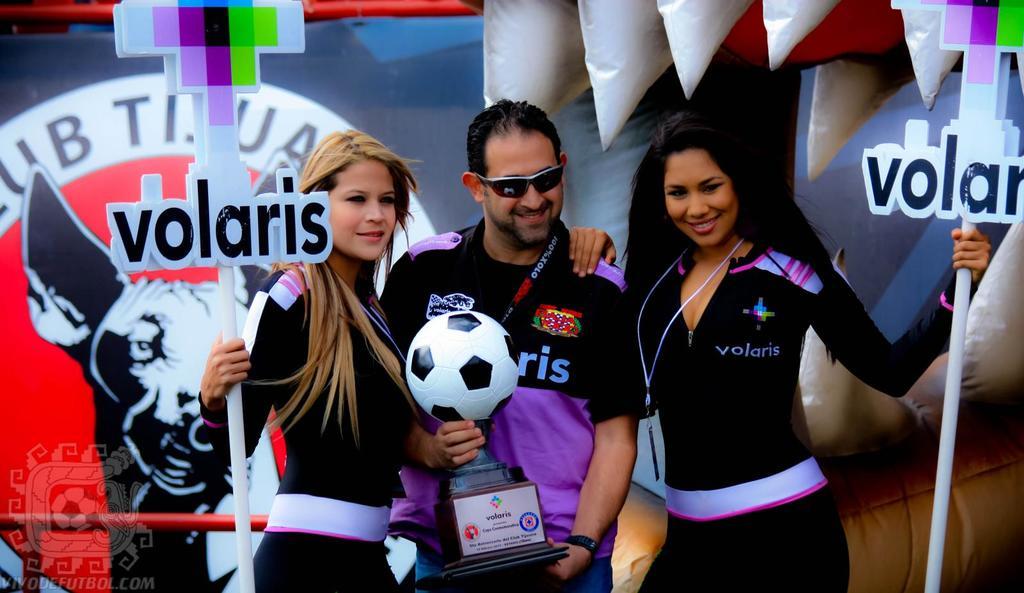What company is the main sponsor of this event?
Your answer should be compact. Volaris. Does this photo show a website in the bottom left?
Provide a succinct answer. Yes. 